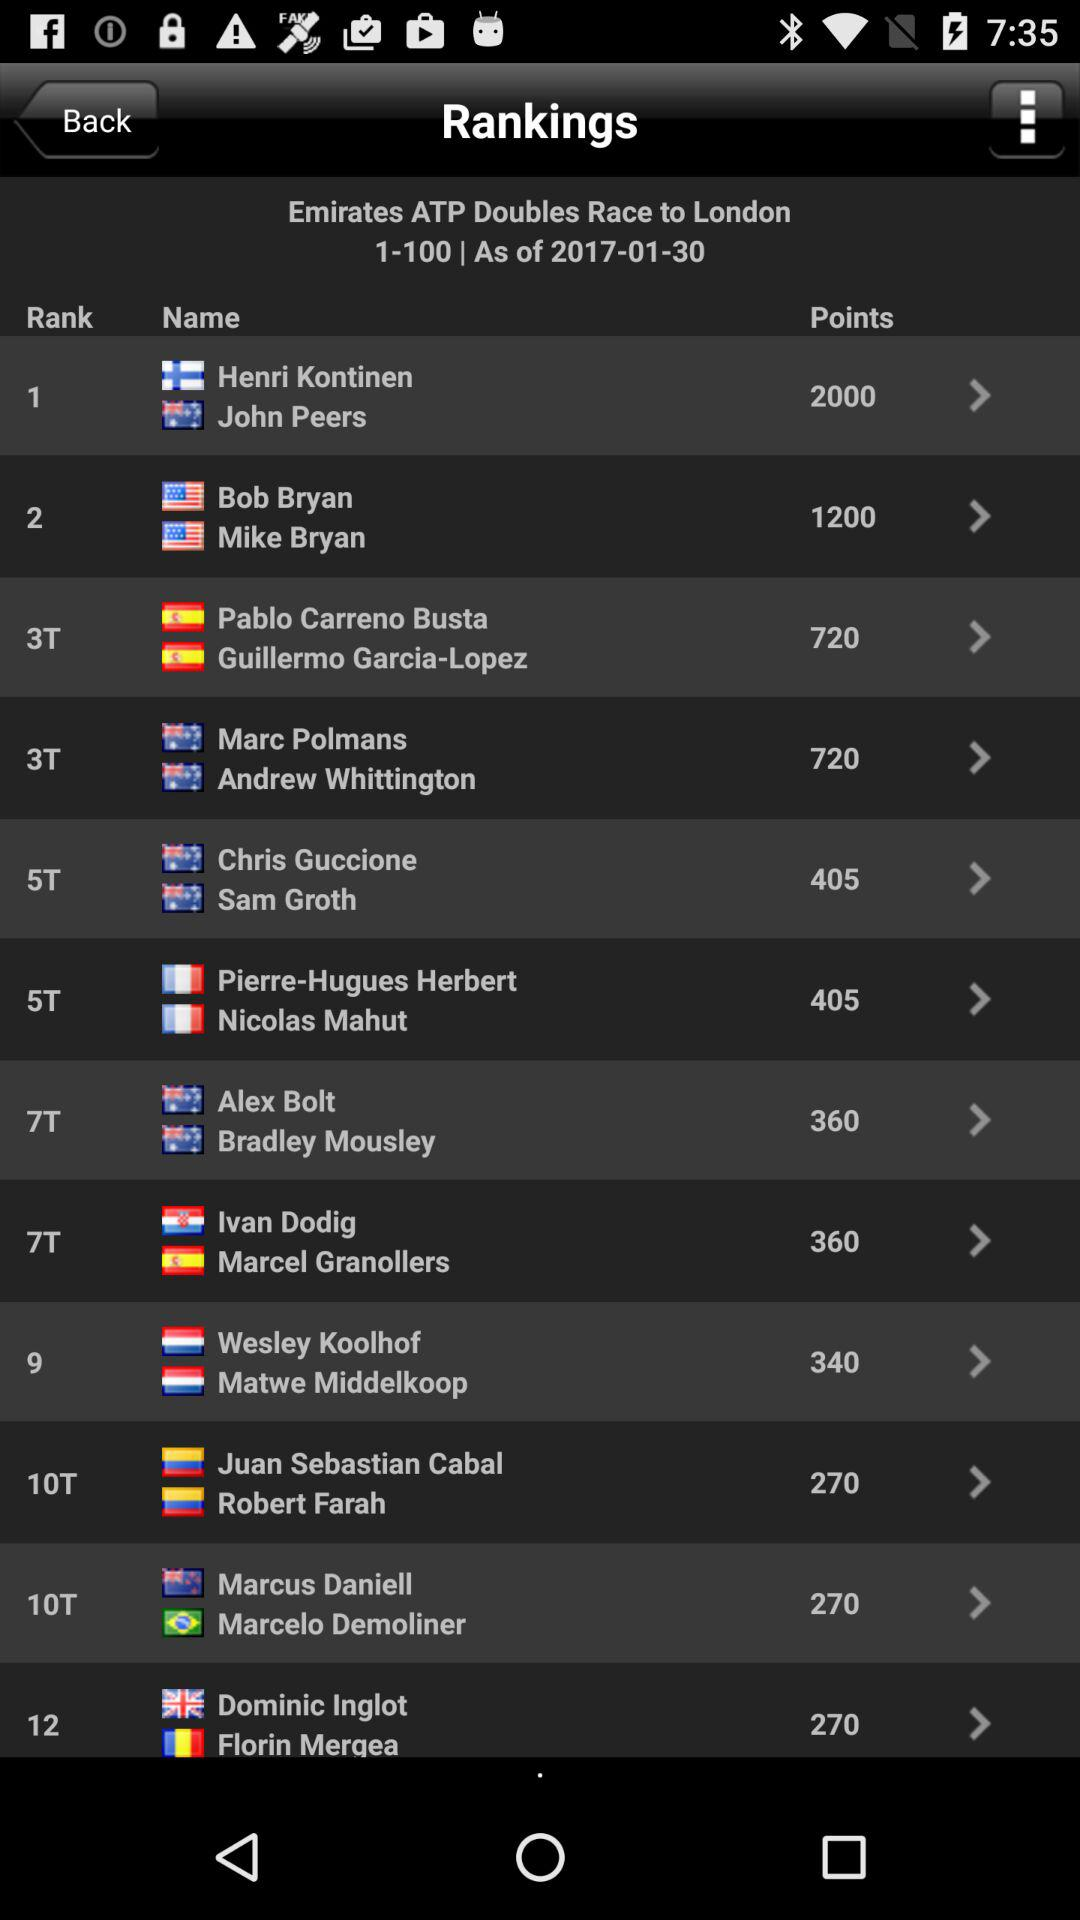What is the shown date? The shown date is January 30, 2017. 